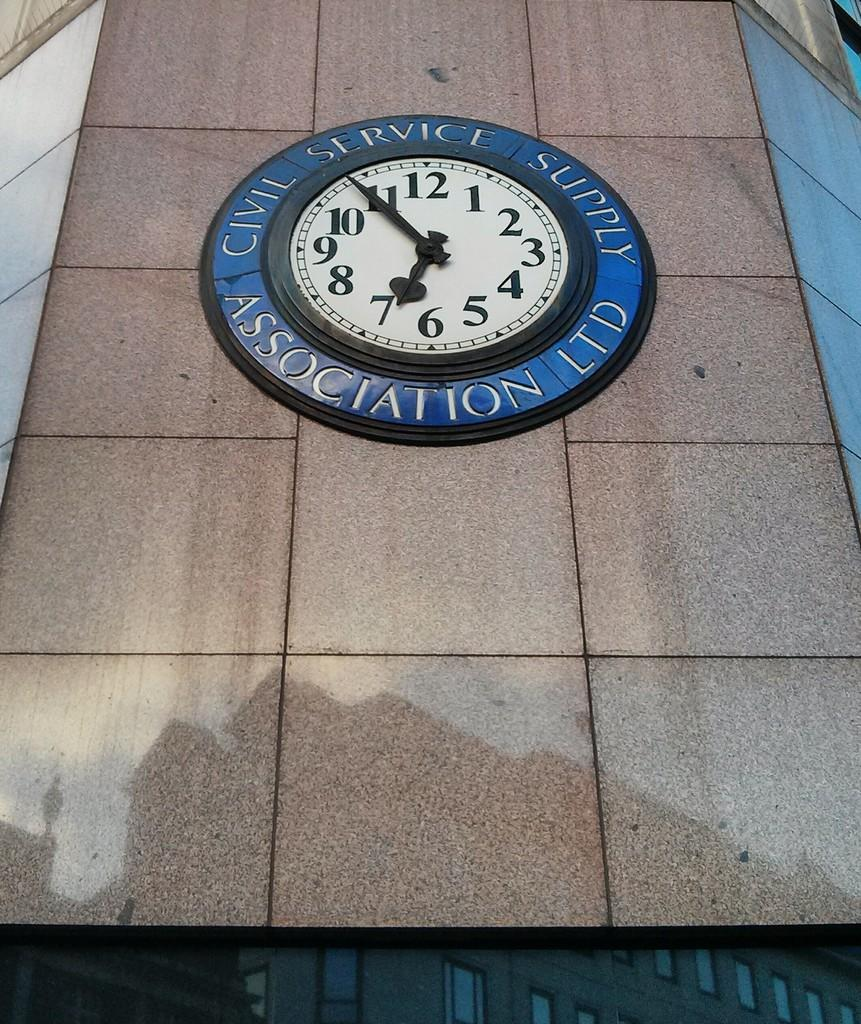<image>
Summarize the visual content of the image. A clock built into a wall that says Civil Service Association Ltd. 